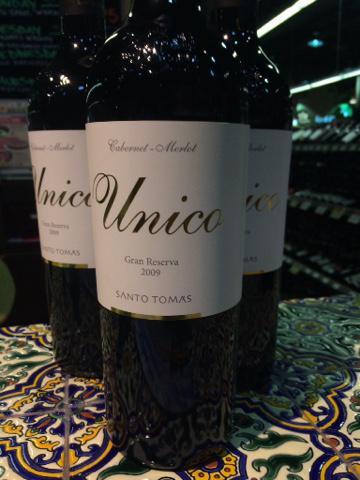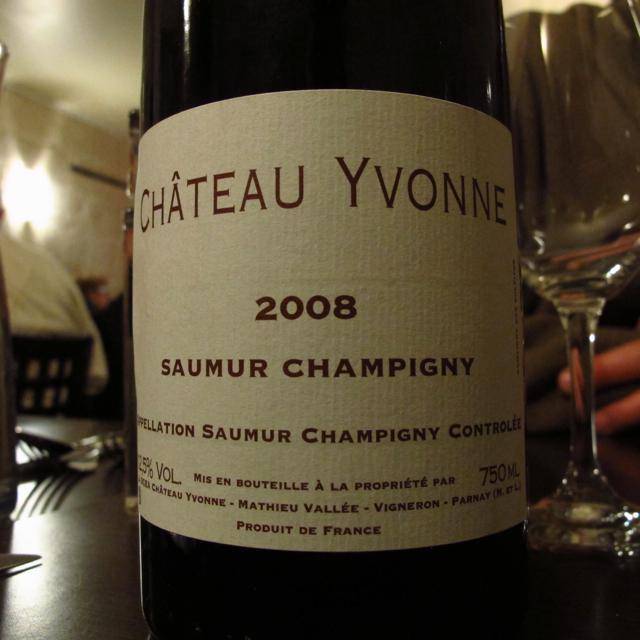The first image is the image on the left, the second image is the image on the right. Given the left and right images, does the statement "there is a half filled wine glas next to a wine bottle" hold true? Answer yes or no. No. The first image is the image on the left, the second image is the image on the right. Considering the images on both sides, is "A full glass of wine is to the left of a bottle of wine on in the right image." valid? Answer yes or no. No. 